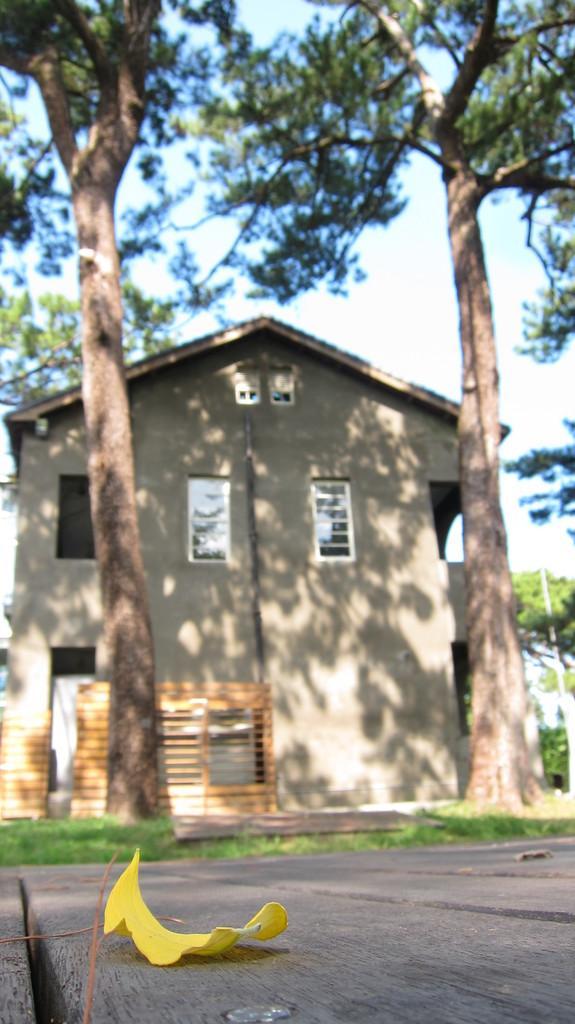In one or two sentences, can you explain what this image depicts? In the picture I can see a house and glass windows. I can see two trees on the side of the road. I can see a leaf on the road on the bottom left side of the picture. 